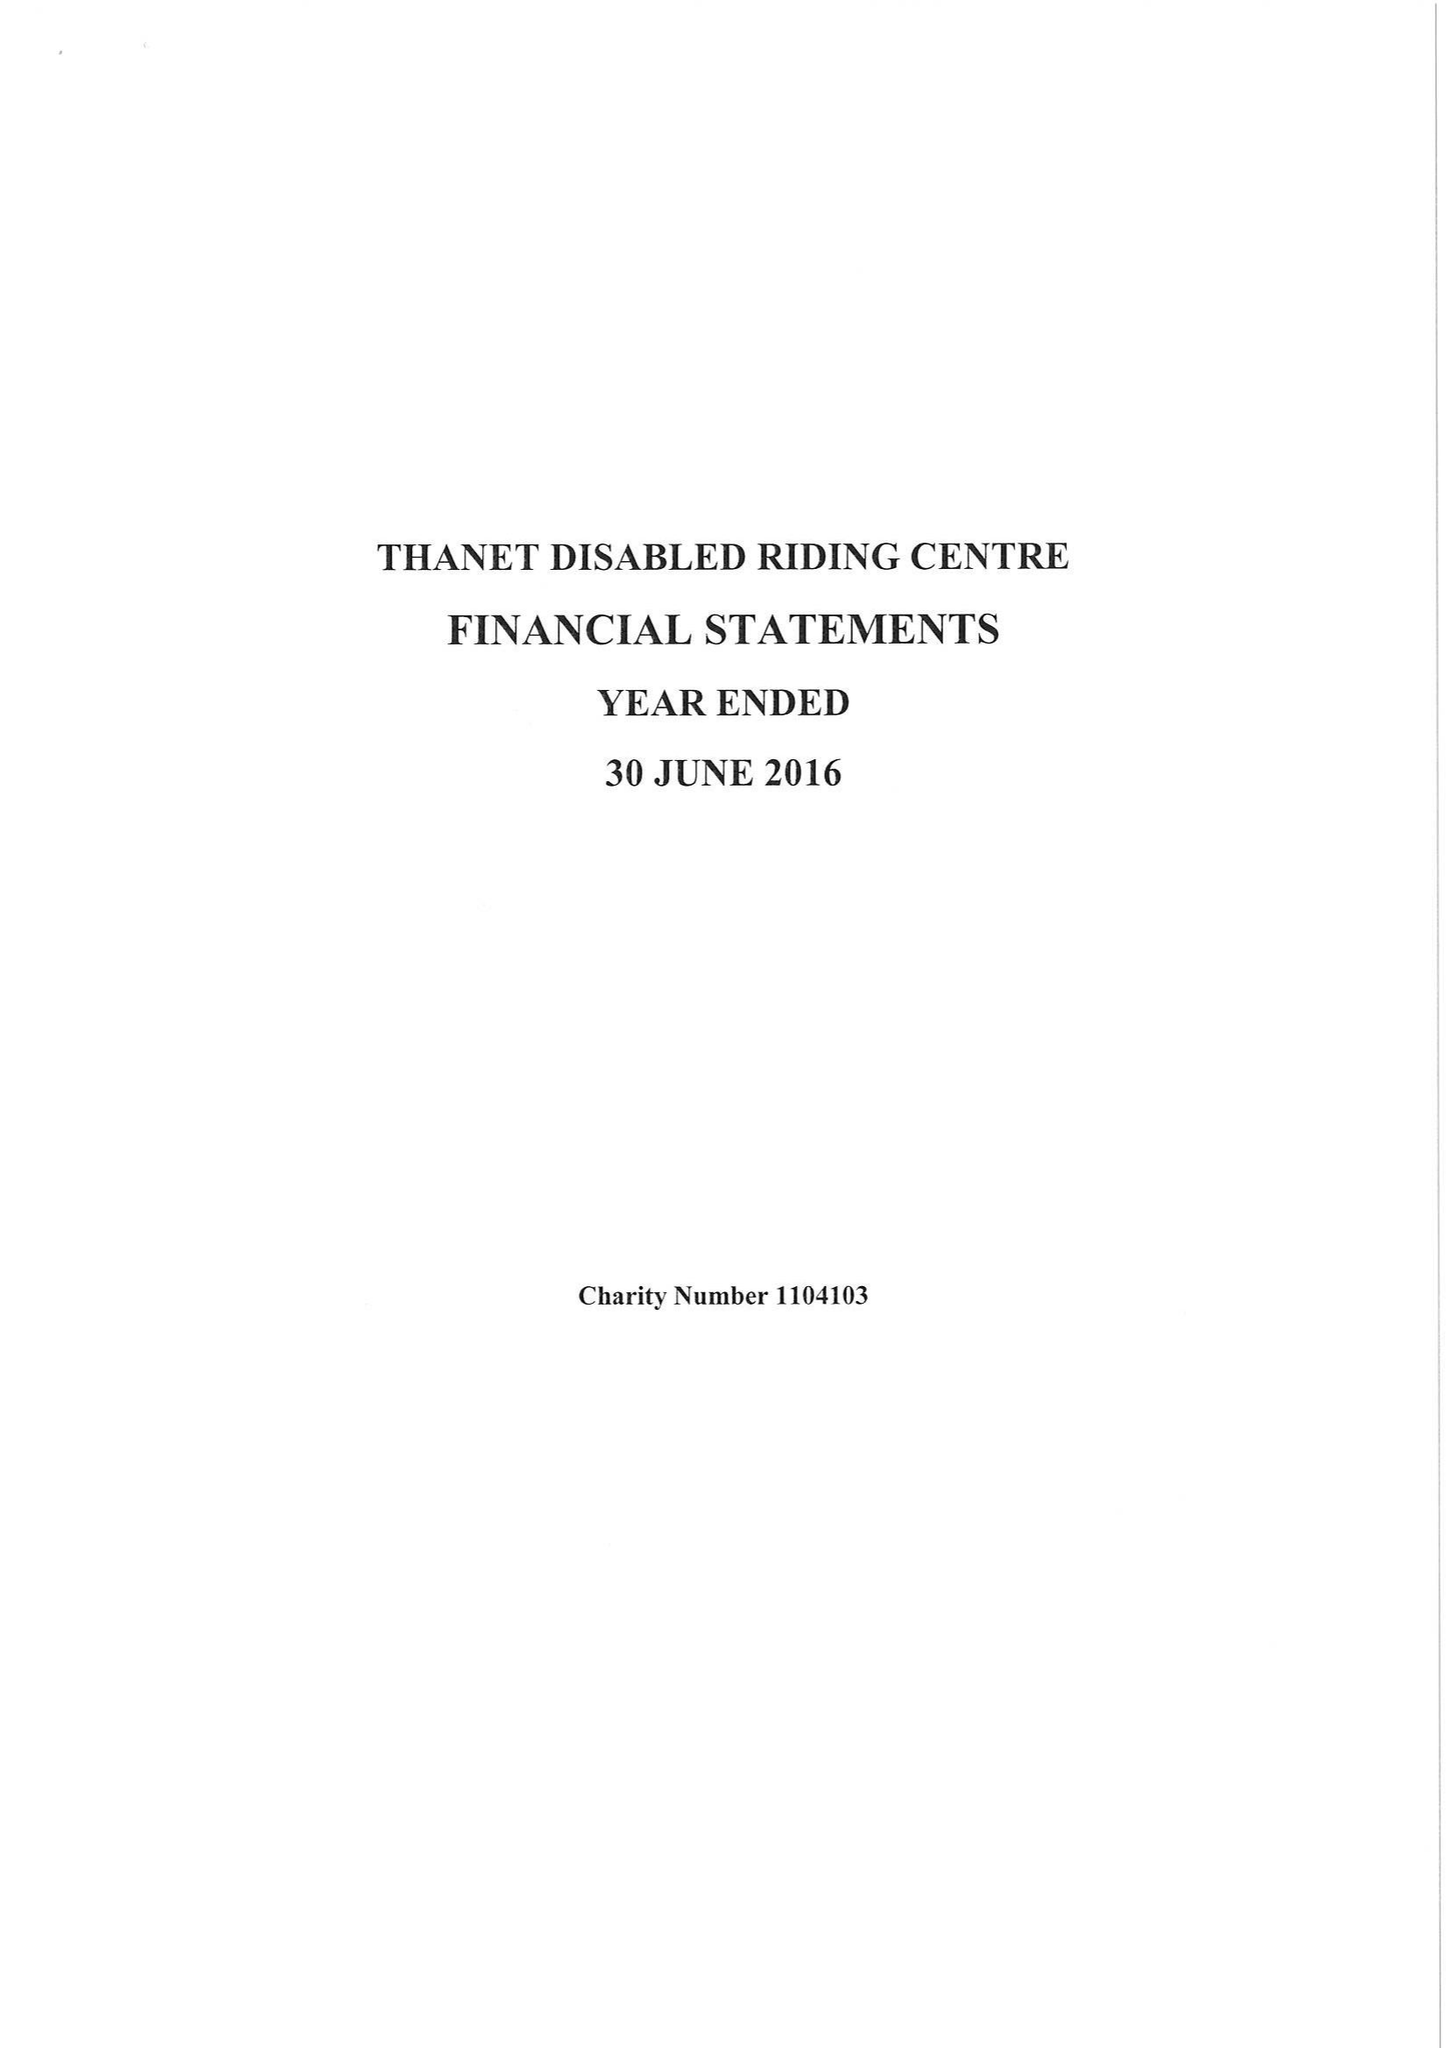What is the value for the income_annually_in_british_pounds?
Answer the question using a single word or phrase. 32697.00 